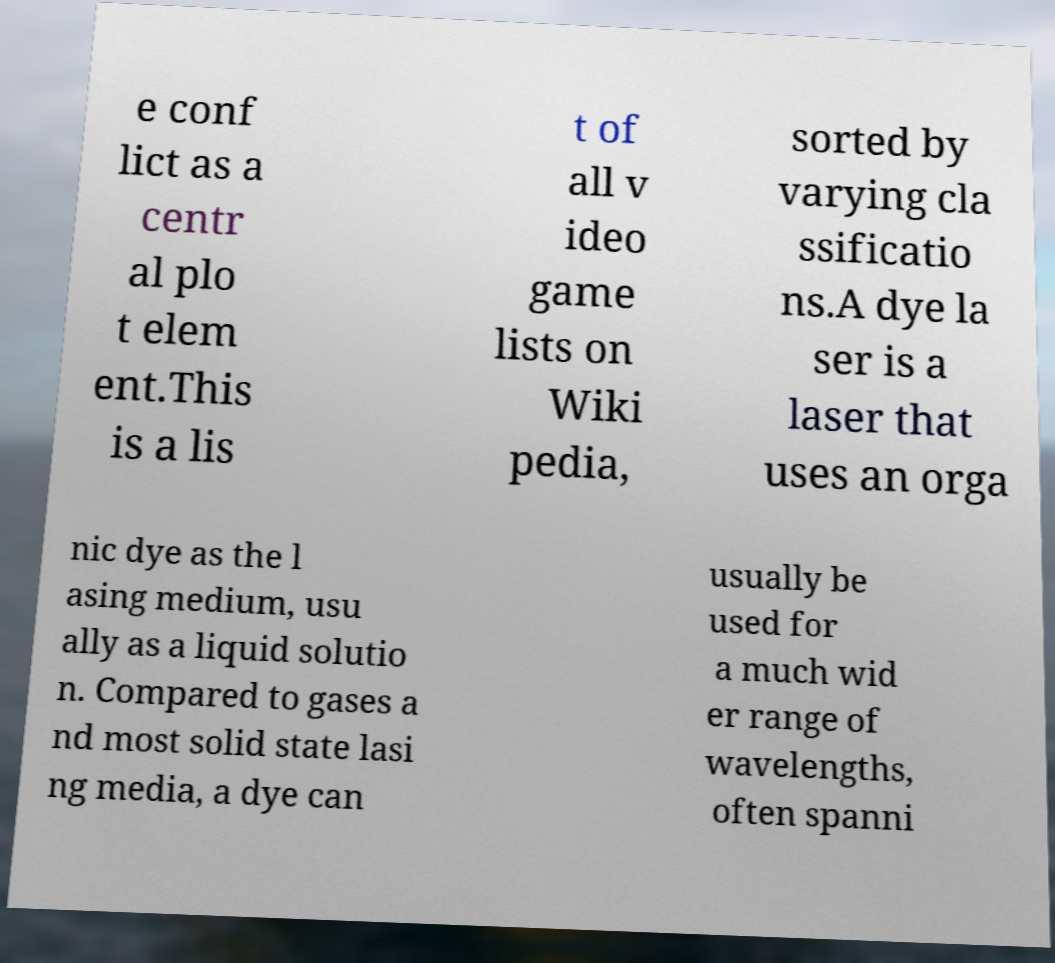Can you accurately transcribe the text from the provided image for me? e conf lict as a centr al plo t elem ent.This is a lis t of all v ideo game lists on Wiki pedia, sorted by varying cla ssificatio ns.A dye la ser is a laser that uses an orga nic dye as the l asing medium, usu ally as a liquid solutio n. Compared to gases a nd most solid state lasi ng media, a dye can usually be used for a much wid er range of wavelengths, often spanni 